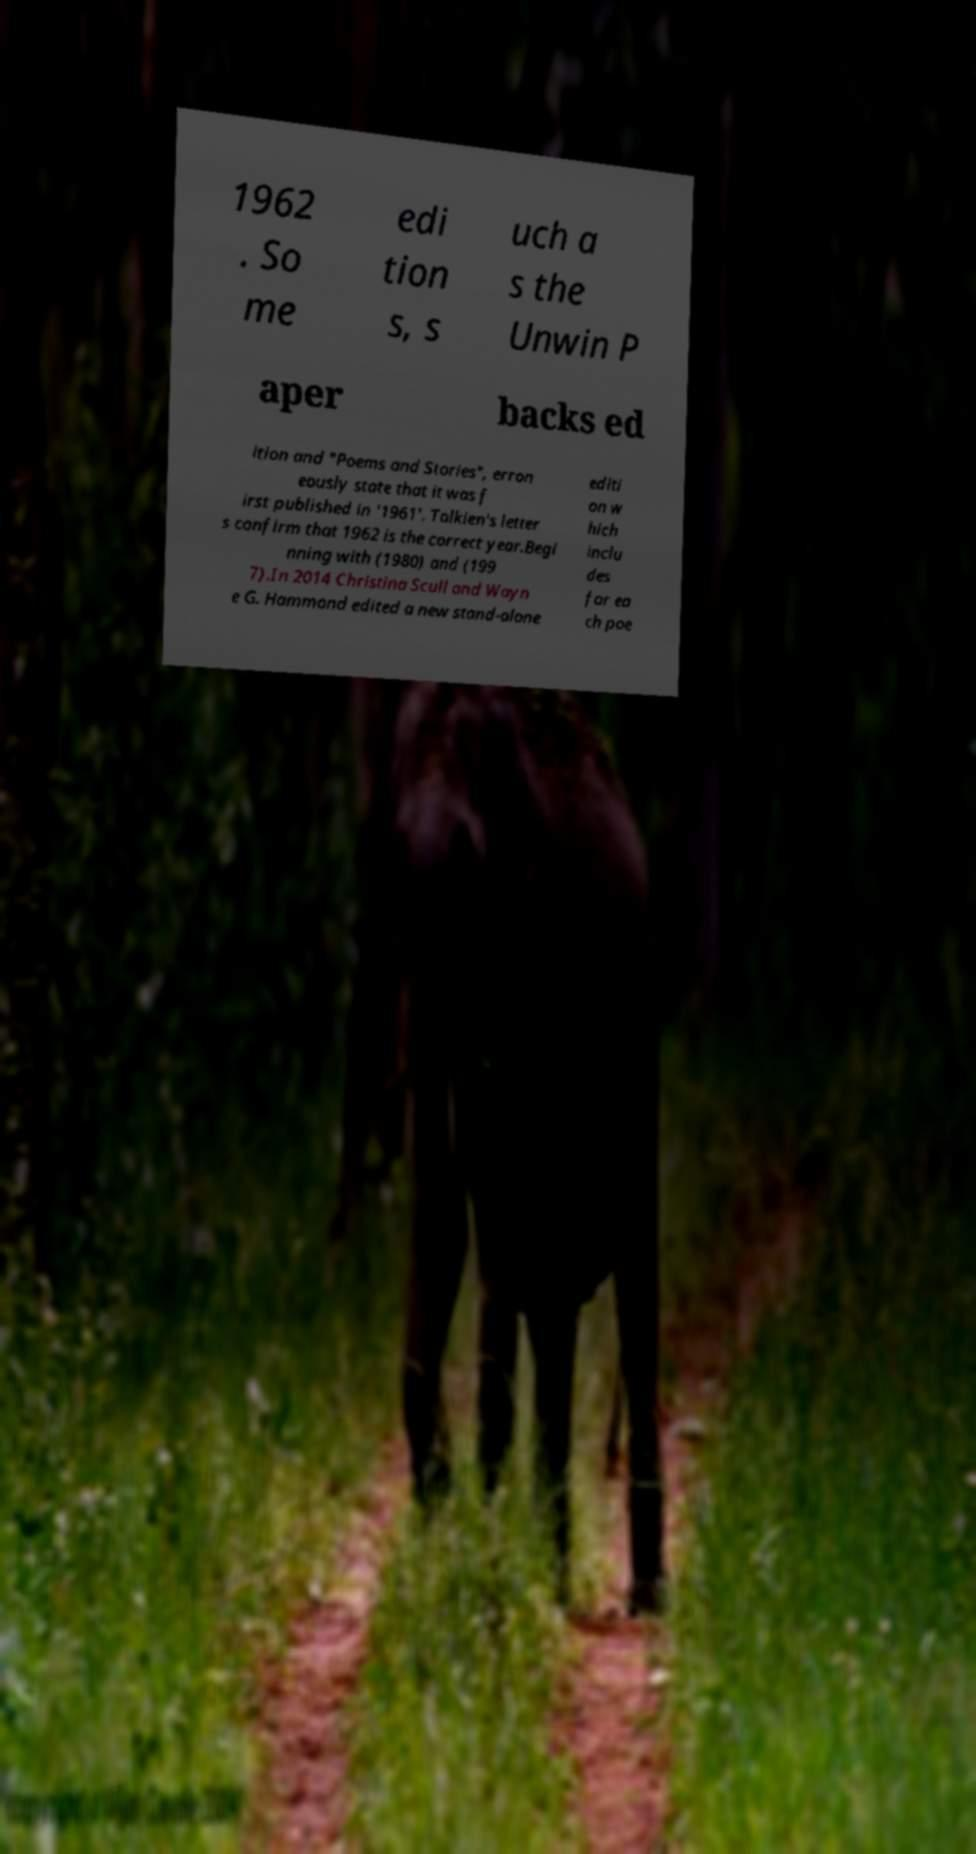Could you extract and type out the text from this image? 1962 . So me edi tion s, s uch a s the Unwin P aper backs ed ition and "Poems and Stories", erron eously state that it was f irst published in '1961'. Tolkien's letter s confirm that 1962 is the correct year.Begi nning with (1980) and (199 7).In 2014 Christina Scull and Wayn e G. Hammond edited a new stand-alone editi on w hich inclu des for ea ch poe 